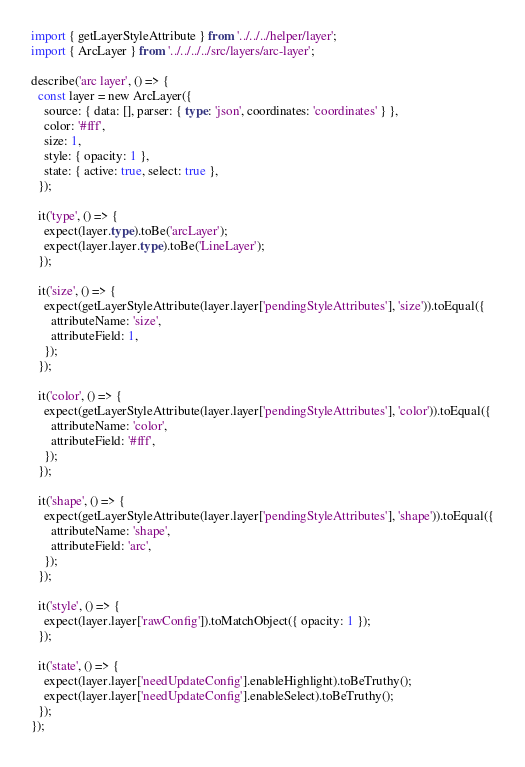Convert code to text. <code><loc_0><loc_0><loc_500><loc_500><_TypeScript_>import { getLayerStyleAttribute } from '../../../helper/layer';
import { ArcLayer } from '../../../../src/layers/arc-layer';

describe('arc layer', () => {
  const layer = new ArcLayer({
    source: { data: [], parser: { type: 'json', coordinates: 'coordinates' } },
    color: '#fff',
    size: 1,
    style: { opacity: 1 },
    state: { active: true, select: true },
  });

  it('type', () => {
    expect(layer.type).toBe('arcLayer');
    expect(layer.layer.type).toBe('LineLayer');
  });

  it('size', () => {
    expect(getLayerStyleAttribute(layer.layer['pendingStyleAttributes'], 'size')).toEqual({
      attributeName: 'size',
      attributeField: 1,
    });
  });

  it('color', () => {
    expect(getLayerStyleAttribute(layer.layer['pendingStyleAttributes'], 'color')).toEqual({
      attributeName: 'color',
      attributeField: '#fff',
    });
  });

  it('shape', () => {
    expect(getLayerStyleAttribute(layer.layer['pendingStyleAttributes'], 'shape')).toEqual({
      attributeName: 'shape',
      attributeField: 'arc',
    });
  });

  it('style', () => {
    expect(layer.layer['rawConfig']).toMatchObject({ opacity: 1 });
  });

  it('state', () => {
    expect(layer.layer['needUpdateConfig'].enableHighlight).toBeTruthy();
    expect(layer.layer['needUpdateConfig'].enableSelect).toBeTruthy();
  });
});
</code> 